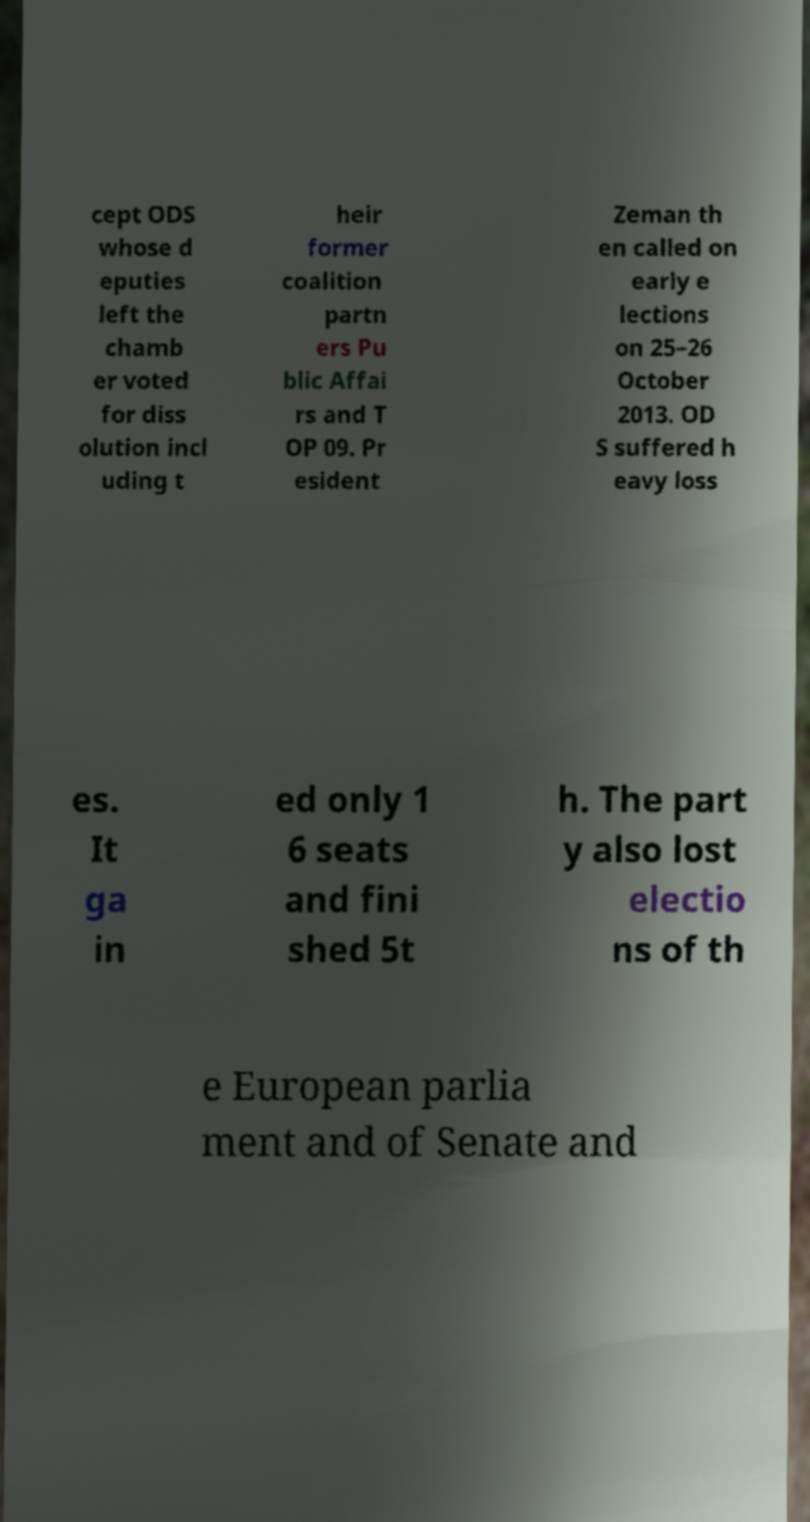Can you read and provide the text displayed in the image?This photo seems to have some interesting text. Can you extract and type it out for me? cept ODS whose d eputies left the chamb er voted for diss olution incl uding t heir former coalition partn ers Pu blic Affai rs and T OP 09. Pr esident Zeman th en called on early e lections on 25–26 October 2013. OD S suffered h eavy loss es. It ga in ed only 1 6 seats and fini shed 5t h. The part y also lost electio ns of th e European parlia ment and of Senate and 